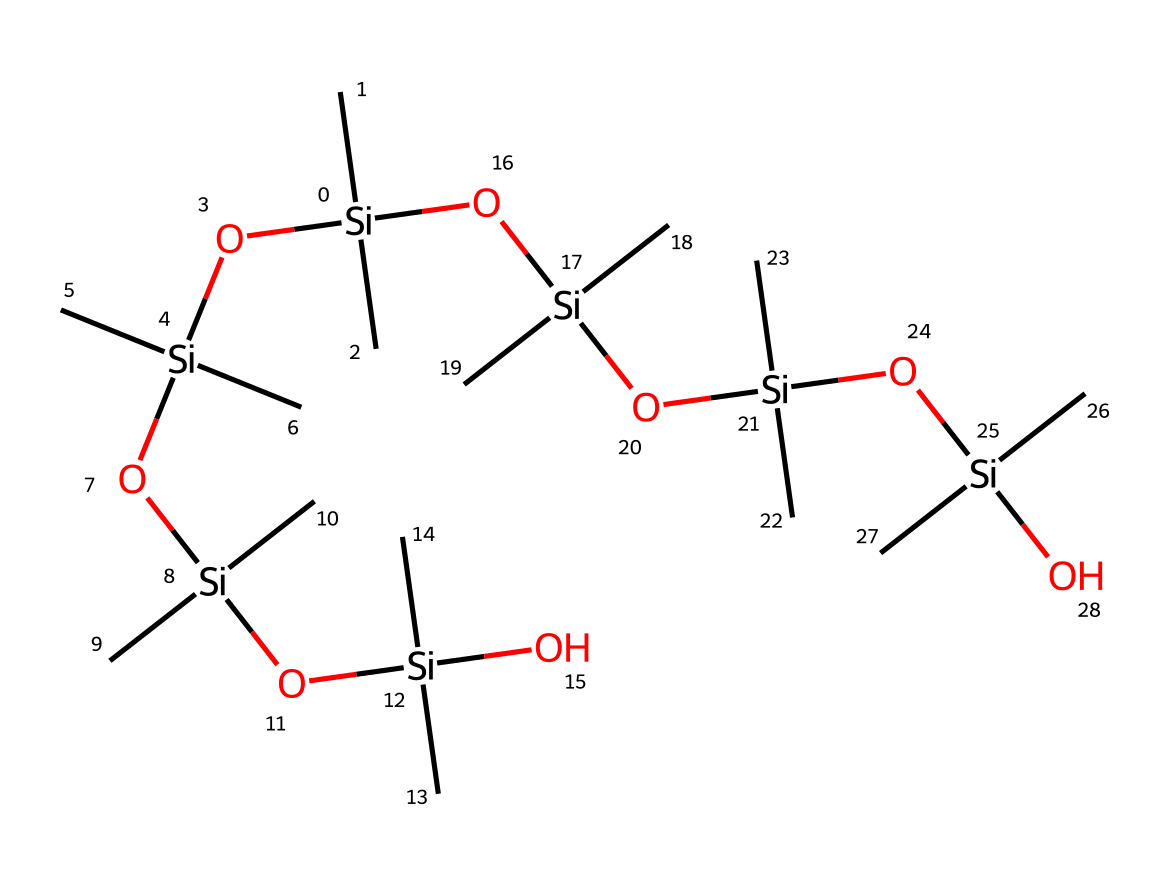how many silicon atoms are present in the chemical structure? Counting the silicon atoms in the provided SMILES notation, there are six occurrences of "Si" which indicates six silicon atoms.
Answer: six what type of bonds primarily connect the silicon atoms in this structure? In the SMILES notation, the silicon atoms are primarily connected through single bonds, as indicated by the lack of any double or triple bond symbols.
Answer: single what is the primary functional group indicated in the structure? The presence of the hydroxyl groups (–OH) bonded to silicon atoms indicates that the primary functional group is silanol. This is evident from observing the "O" connected to "Si" in the structure.
Answer: silanol how many ether linkages are present in the chemical structure? Analyzing the structure, there are eight instances where "-Si-O-Si-" occurs, indicating four ether linkages formed by the silicone polymer chains.
Answer: four does this structure contain any branched or linear arrangements of the polymer? The arrangement showcases a branched structure due to the presence of multiple silicon atoms connected to a central silicon, forming a branched network rather than a linear chain.
Answer: branched what property is most likely enhanced by the presence of flexible molds made from this structure? The flexibility of the silicone polymer made from this structure is enhanced due to its molecular arrangement which allows for easy bending and shaping, characteristic of silicone materials.
Answer: flexibility 